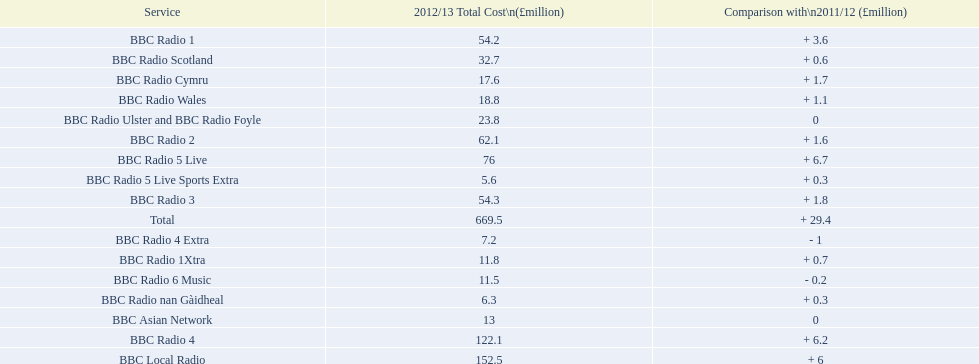What is the most amount of money spent to run a station in 2012/13? 152.5. What station costed 152.5 million pounds to run in this time? BBC Local Radio. 